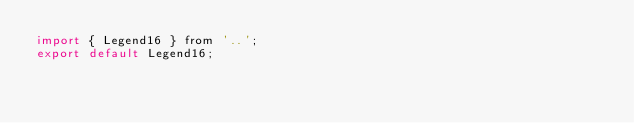<code> <loc_0><loc_0><loc_500><loc_500><_JavaScript_>import { Legend16 } from '..';
export default Legend16;
</code> 